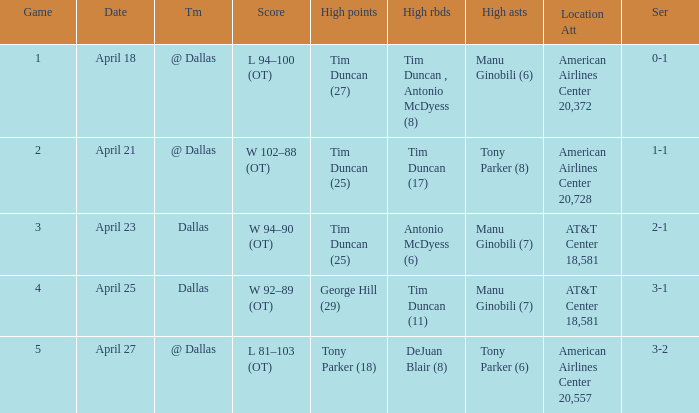When george hill (29) has the highest amount of points what is the date? April 25. Could you parse the entire table as a dict? {'header': ['Game', 'Date', 'Tm', 'Score', 'High points', 'High rbds', 'High asts', 'Location Att', 'Ser'], 'rows': [['1', 'April 18', '@ Dallas', 'L 94–100 (OT)', 'Tim Duncan (27)', 'Tim Duncan , Antonio McDyess (8)', 'Manu Ginobili (6)', 'American Airlines Center 20,372', '0-1'], ['2', 'April 21', '@ Dallas', 'W 102–88 (OT)', 'Tim Duncan (25)', 'Tim Duncan (17)', 'Tony Parker (8)', 'American Airlines Center 20,728', '1-1'], ['3', 'April 23', 'Dallas', 'W 94–90 (OT)', 'Tim Duncan (25)', 'Antonio McDyess (6)', 'Manu Ginobili (7)', 'AT&T Center 18,581', '2-1'], ['4', 'April 25', 'Dallas', 'W 92–89 (OT)', 'George Hill (29)', 'Tim Duncan (11)', 'Manu Ginobili (7)', 'AT&T Center 18,581', '3-1'], ['5', 'April 27', '@ Dallas', 'L 81–103 (OT)', 'Tony Parker (18)', 'DeJuan Blair (8)', 'Tony Parker (6)', 'American Airlines Center 20,557', '3-2']]} 